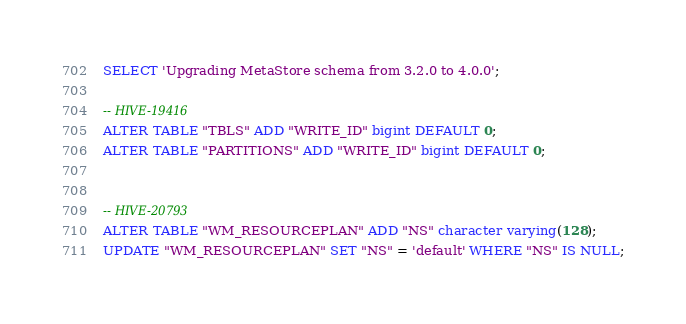Convert code to text. <code><loc_0><loc_0><loc_500><loc_500><_SQL_>SELECT 'Upgrading MetaStore schema from 3.2.0 to 4.0.0';

-- HIVE-19416
ALTER TABLE "TBLS" ADD "WRITE_ID" bigint DEFAULT 0;
ALTER TABLE "PARTITIONS" ADD "WRITE_ID" bigint DEFAULT 0;


-- HIVE-20793
ALTER TABLE "WM_RESOURCEPLAN" ADD "NS" character varying(128);
UPDATE "WM_RESOURCEPLAN" SET "NS" = 'default' WHERE "NS" IS NULL;</code> 